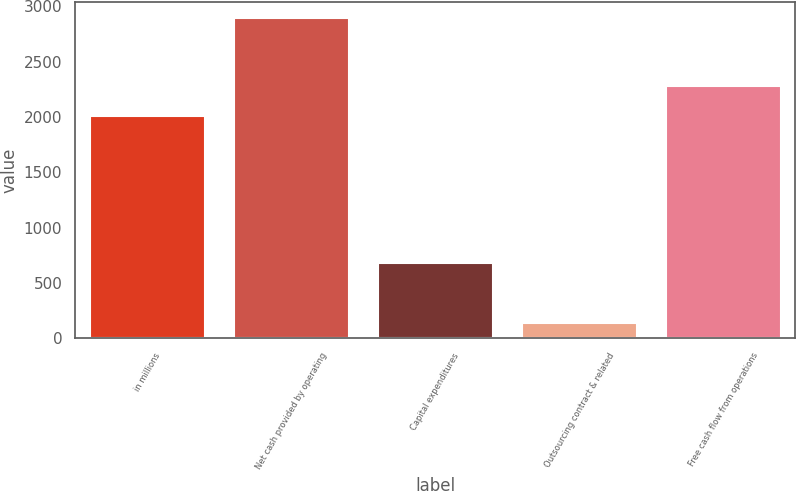Convert chart to OTSL. <chart><loc_0><loc_0><loc_500><loc_500><bar_chart><fcel>in millions<fcel>Net cash provided by operating<fcel>Capital expenditures<fcel>Outsourcing contract & related<fcel>Free cash flow from operations<nl><fcel>2007<fcel>2890<fcel>682<fcel>137<fcel>2282.3<nl></chart> 